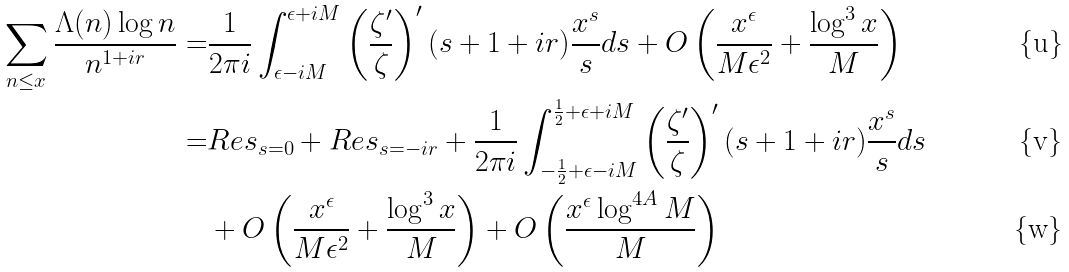Convert formula to latex. <formula><loc_0><loc_0><loc_500><loc_500>\sum _ { n \leq x } \frac { \Lambda ( n ) \log n } { n ^ { 1 + i r } } = & \frac { 1 } { 2 \pi i } \int _ { \epsilon - i M } ^ { \epsilon + i M } \left ( \frac { \zeta ^ { \prime } } { \zeta } \right ) ^ { \prime } ( s + 1 + i r ) \frac { x ^ { s } } { s } d s + O \left ( \frac { x ^ { \epsilon } } { M \epsilon ^ { 2 } } + \frac { \log ^ { 3 } x } { M } \right ) \\ = & R e s _ { s = 0 } + R e s _ { s = - i r } + \frac { 1 } { 2 \pi i } \int _ { - \frac { 1 } { 2 } + \epsilon - i M } ^ { \frac { 1 } { 2 } + \epsilon + i M } \left ( \frac { \zeta ^ { \prime } } { \zeta } \right ) ^ { \prime } ( s + 1 + i r ) \frac { x ^ { s } } { s } d s \\ & + O \left ( \frac { x ^ { \epsilon } } { M \epsilon ^ { 2 } } + \frac { \log ^ { 3 } x } { M } \right ) + O \left ( \frac { x ^ { \epsilon } \log ^ { 4 A } M } { M } \right )</formula> 